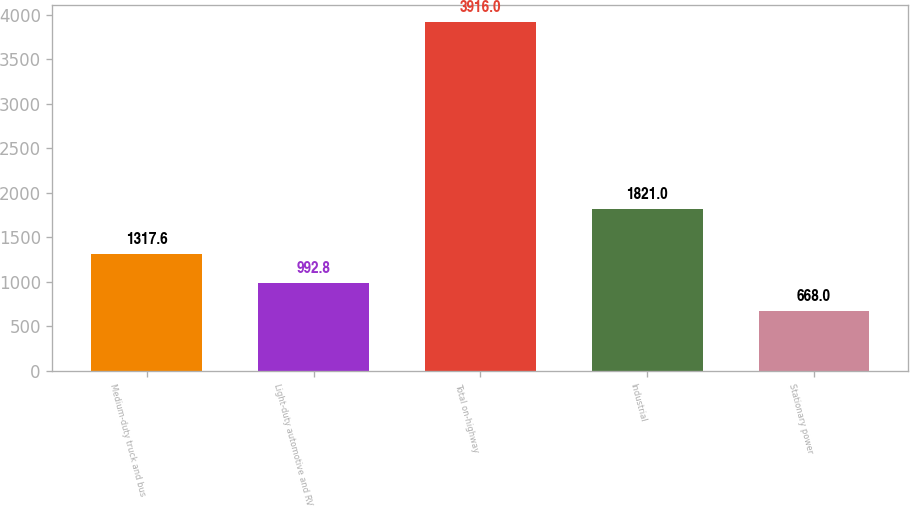Convert chart to OTSL. <chart><loc_0><loc_0><loc_500><loc_500><bar_chart><fcel>Medium-duty truck and bus<fcel>Light-duty automotive and RV<fcel>Total on-highway<fcel>Industrial<fcel>Stationary power<nl><fcel>1317.6<fcel>992.8<fcel>3916<fcel>1821<fcel>668<nl></chart> 